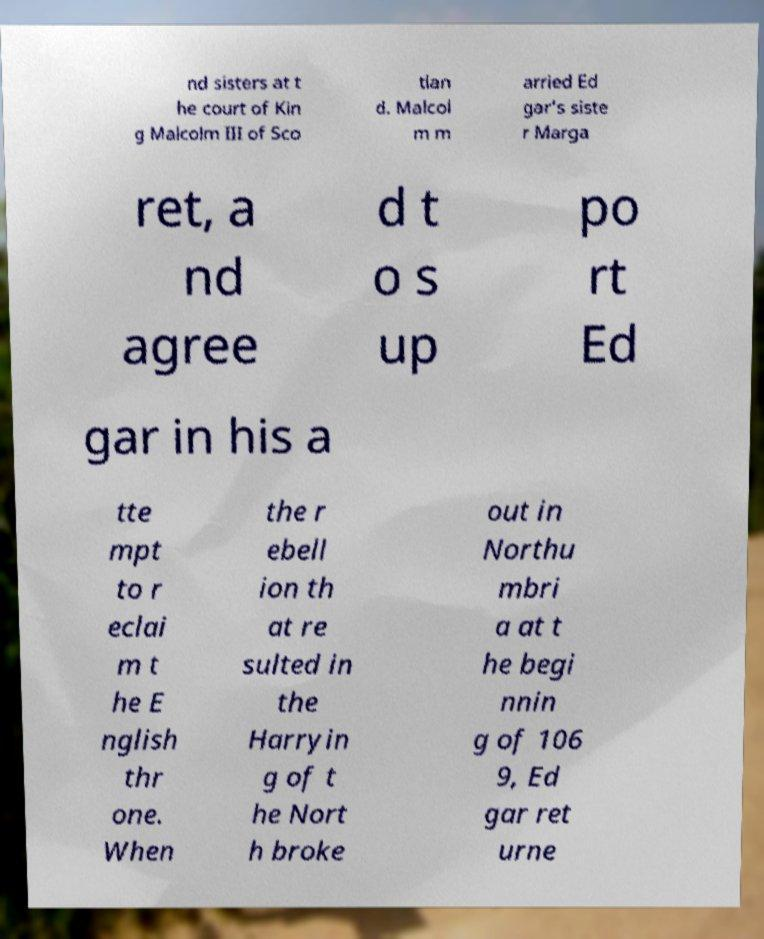For documentation purposes, I need the text within this image transcribed. Could you provide that? nd sisters at t he court of Kin g Malcolm III of Sco tlan d. Malcol m m arried Ed gar's siste r Marga ret, a nd agree d t o s up po rt Ed gar in his a tte mpt to r eclai m t he E nglish thr one. When the r ebell ion th at re sulted in the Harryin g of t he Nort h broke out in Northu mbri a at t he begi nnin g of 106 9, Ed gar ret urne 